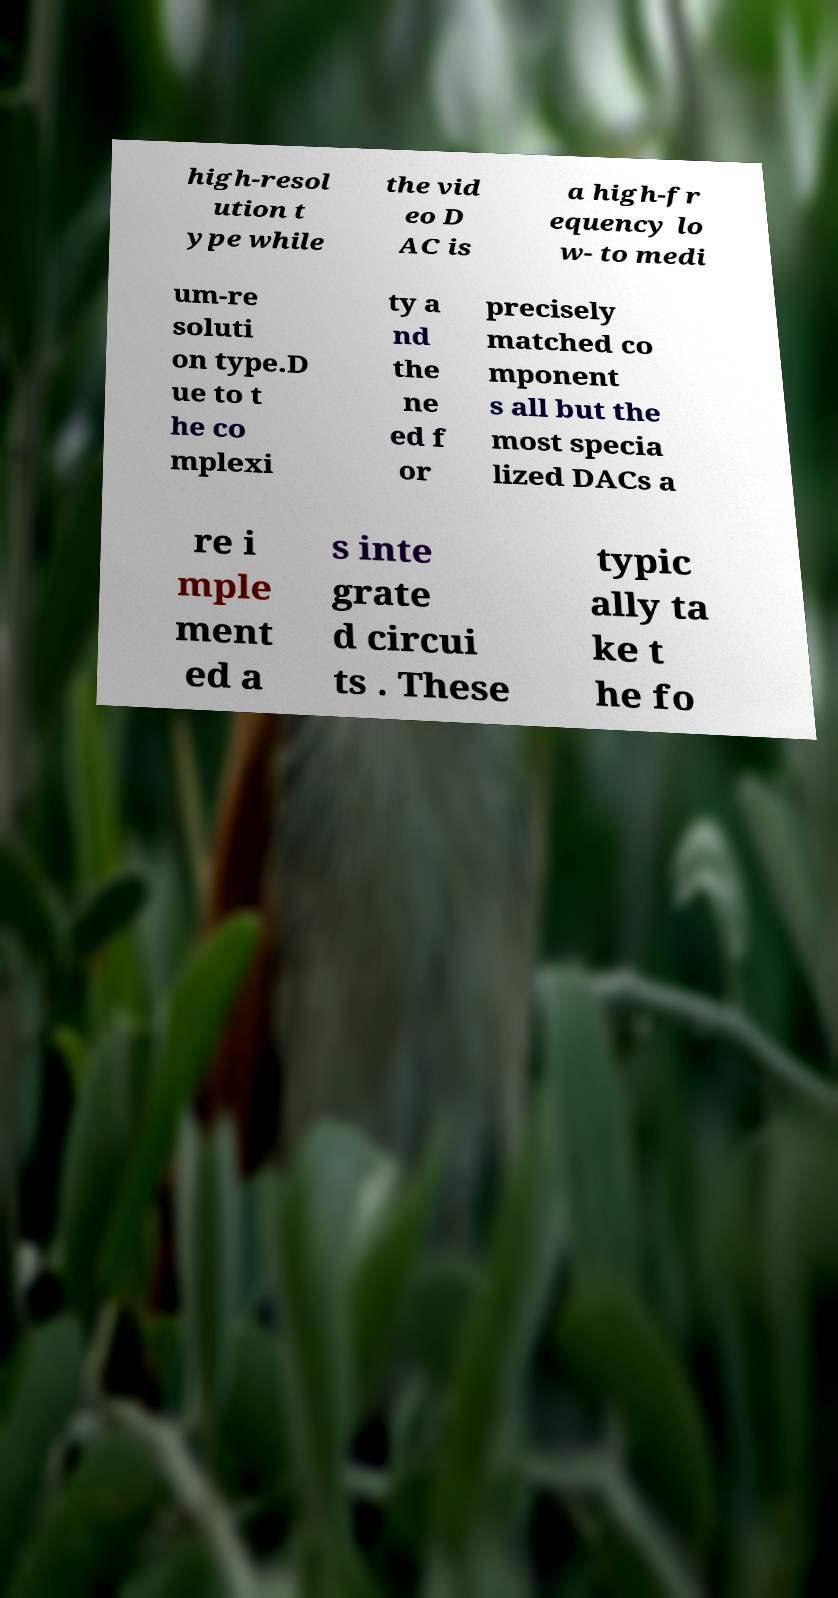Can you read and provide the text displayed in the image?This photo seems to have some interesting text. Can you extract and type it out for me? high-resol ution t ype while the vid eo D AC is a high-fr equency lo w- to medi um-re soluti on type.D ue to t he co mplexi ty a nd the ne ed f or precisely matched co mponent s all but the most specia lized DACs a re i mple ment ed a s inte grate d circui ts . These typic ally ta ke t he fo 